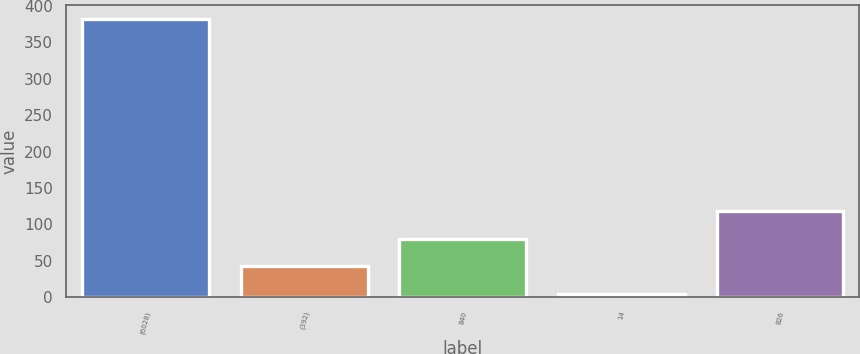Convert chart to OTSL. <chart><loc_0><loc_0><loc_500><loc_500><bar_chart><fcel>(6028)<fcel>(392)<fcel>840<fcel>14<fcel>826<nl><fcel>382<fcel>42.7<fcel>80.4<fcel>5<fcel>118.1<nl></chart> 